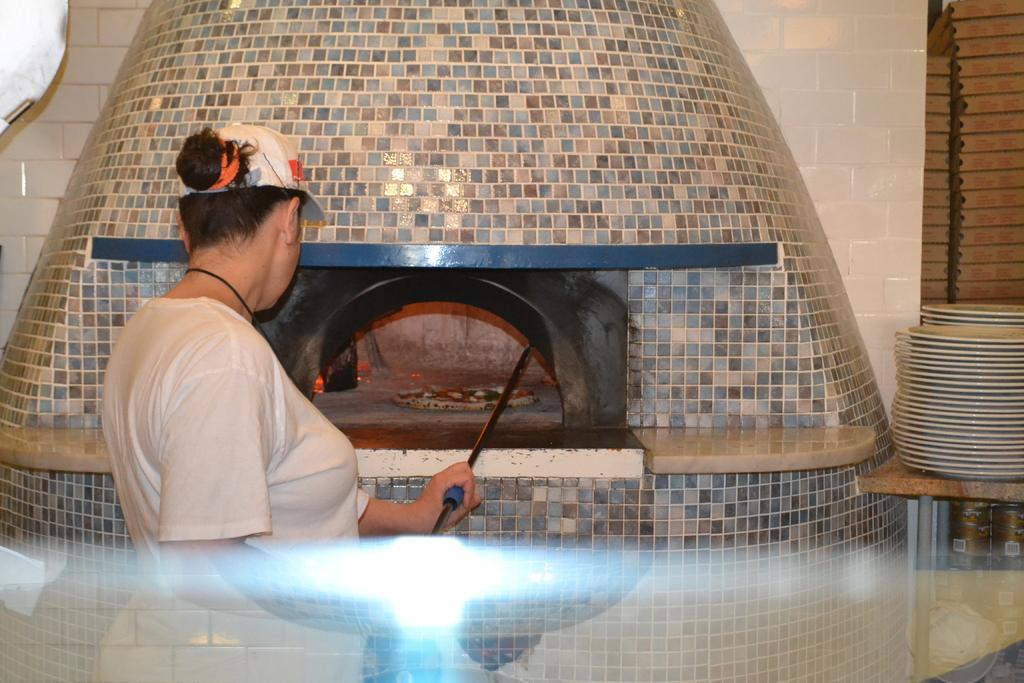Please provide a concise description of this image. In this picture there is a woman wearing white color t- shirt with cap is holding a rod in the grill burner. Behind you can see white and blue color burner. In the background there is a white cladding tiles and some plates placed on the top. 